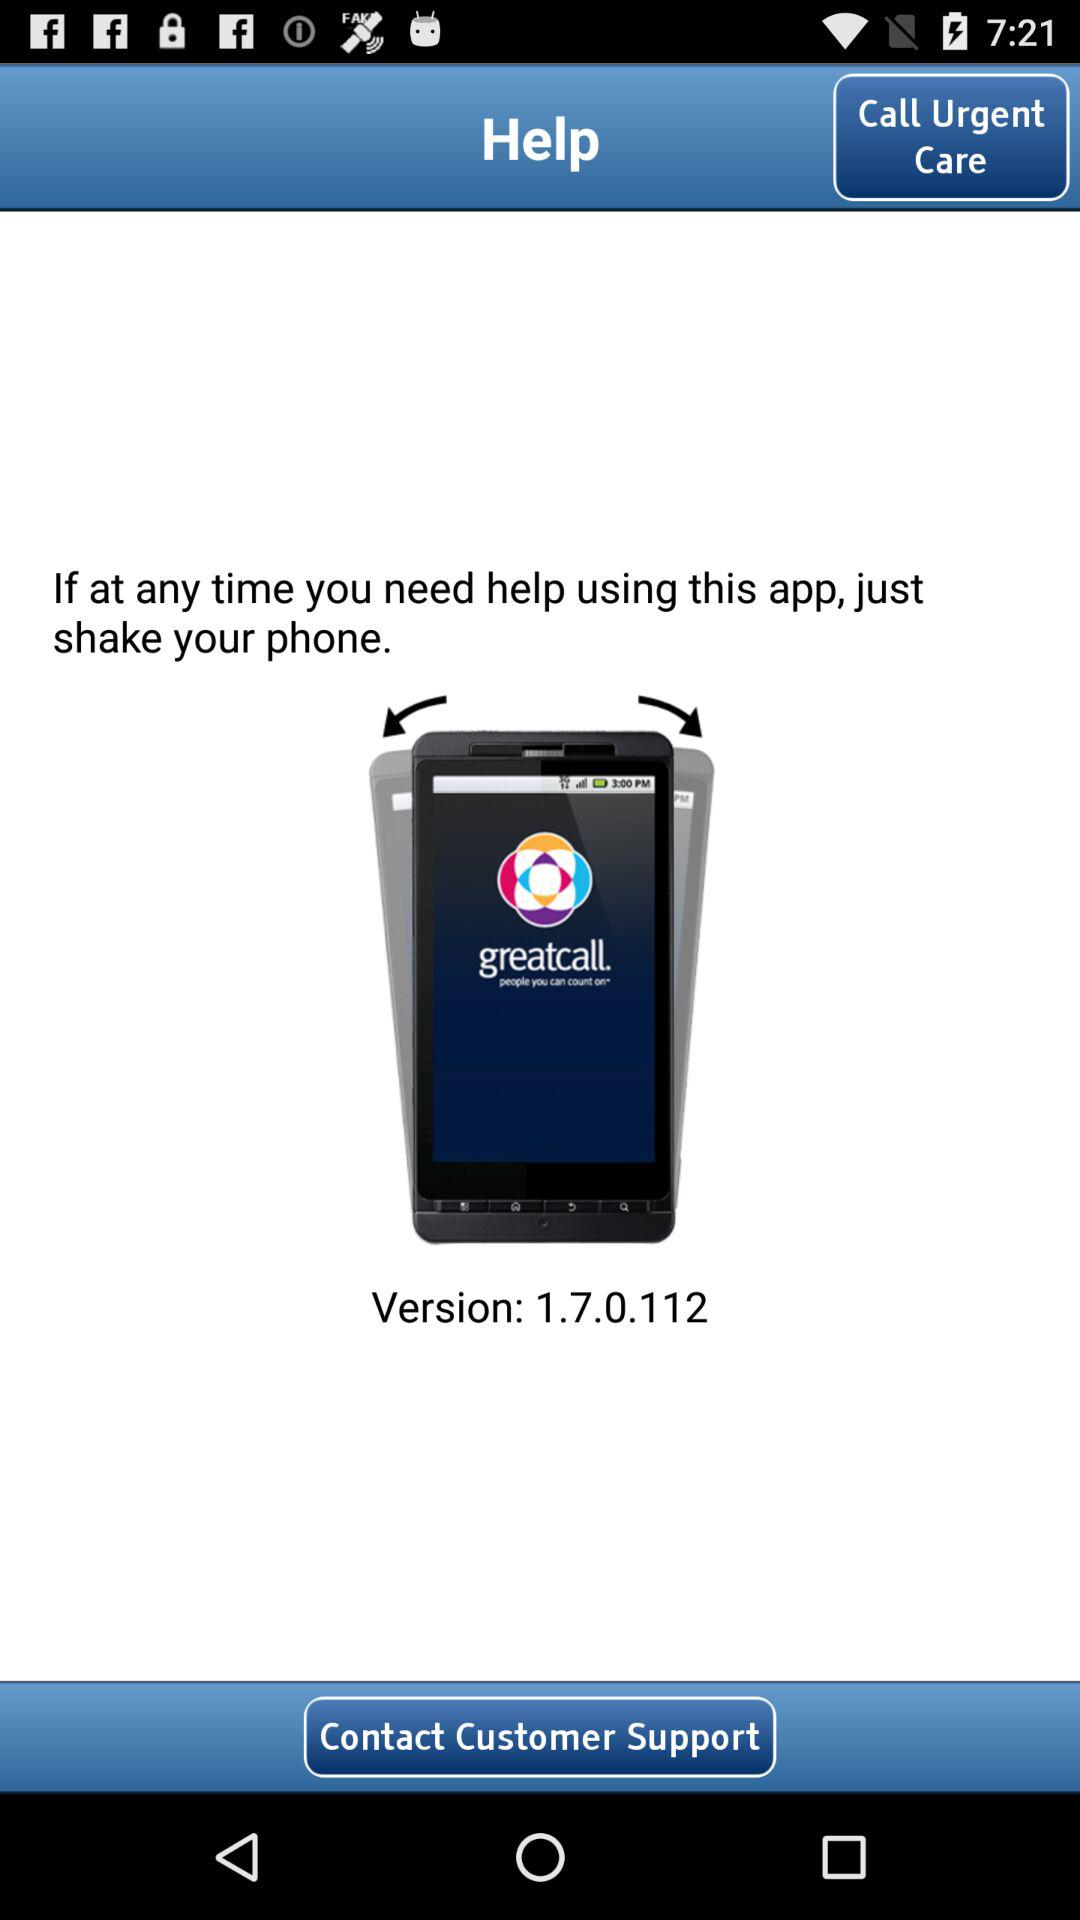What should we do if we need help using the application? You just need to shake your phone. 